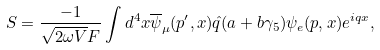<formula> <loc_0><loc_0><loc_500><loc_500>S = \frac { - 1 } { \sqrt { 2 \omega V } F } \int d ^ { 4 } x \overline { \psi } _ { \mu } ( p ^ { \prime } , x ) \hat { q } ( a + b \gamma _ { 5 } ) \psi _ { e } ( p , x ) e ^ { i q x } ,</formula> 